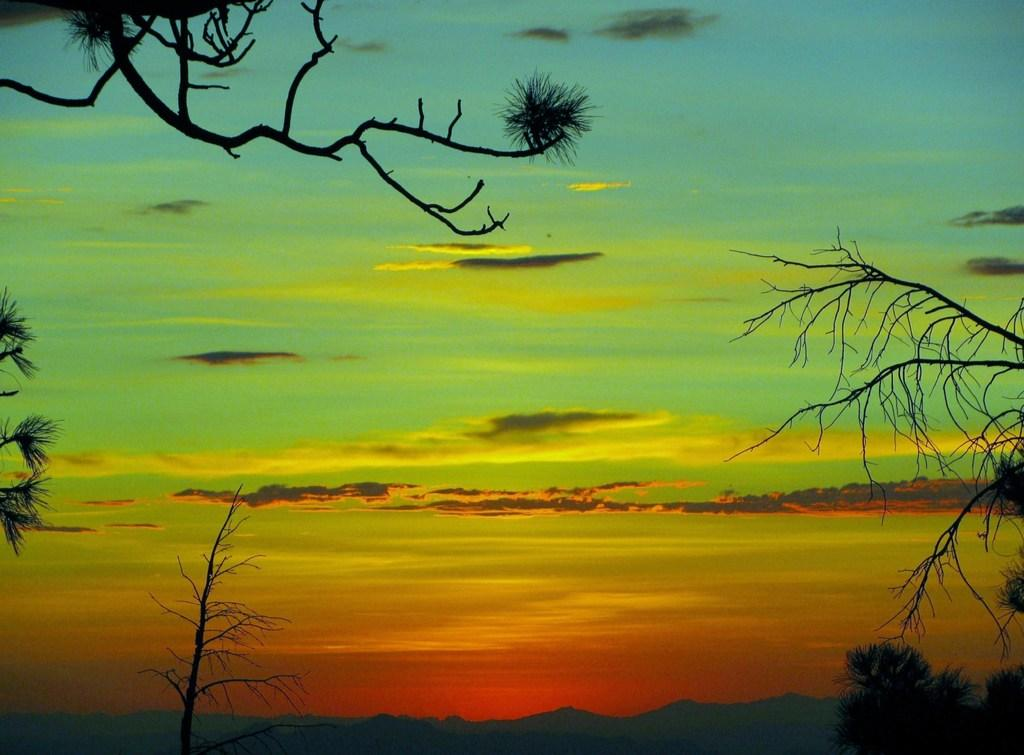What type of natural features can be seen in the image? There are trees and mountains in the image. What part of the natural environment is visible in the image? The sky is visible in the image and has a colorful appearance. What type of disease is being treated in the bedroom in the image? There is no bedroom or disease present in the image; it features trees, mountains, and a colorful sky. 